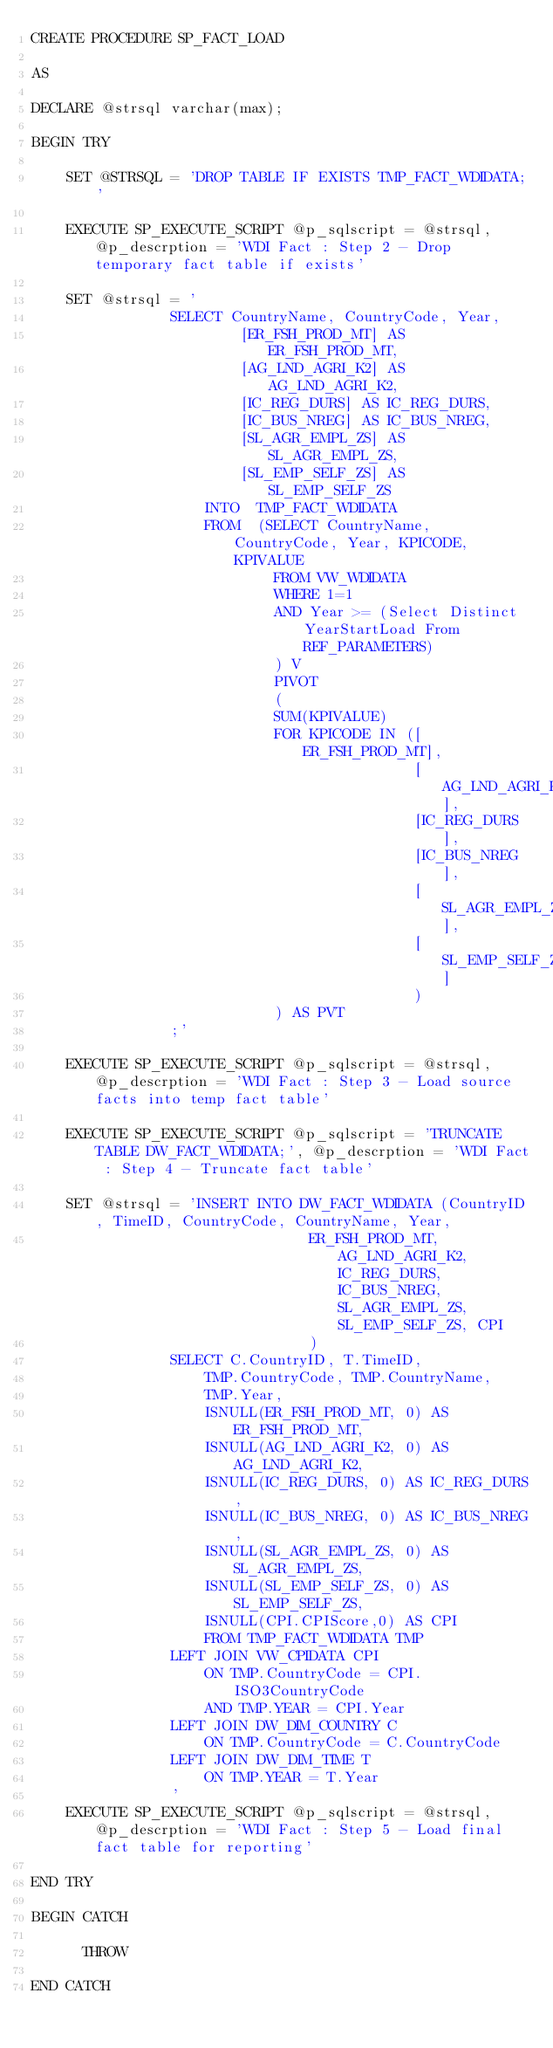<code> <loc_0><loc_0><loc_500><loc_500><_SQL_>CREATE PROCEDURE SP_FACT_LOAD

AS

DECLARE @strsql varchar(max);

BEGIN TRY

    SET @STRSQL = 'DROP TABLE IF EXISTS TMP_FACT_WDIDATA;'
    
    EXECUTE SP_EXECUTE_SCRIPT @p_sqlscript = @strsql, @p_descrption = 'WDI Fact : Step 2 - Drop temporary fact table if exists' 
    
    SET @strsql = '
                SELECT CountryName, CountryCode, Year, 
                        [ER_FSH_PROD_MT] AS ER_FSH_PROD_MT,
                        [AG_LND_AGRI_K2] AS AG_LND_AGRI_K2,
                        [IC_REG_DURS] AS IC_REG_DURS,
                        [IC_BUS_NREG] AS IC_BUS_NREG,
                        [SL_AGR_EMPL_ZS] AS SL_AGR_EMPL_ZS,
                        [SL_EMP_SELF_ZS] AS SL_EMP_SELF_ZS
                    INTO  TMP_FACT_WDIDATA
                    FROM  (SELECT CountryName, CountryCode, Year, KPICODE, KPIVALUE
                            FROM VW_WDIDATA
                            WHERE 1=1
                            AND Year >= (Select Distinct YearStartLoad From REF_PARAMETERS)
                            ) V
                            PIVOT
                            (
                            SUM(KPIVALUE)
                            FOR KPICODE IN ([ER_FSH_PROD_MT],
                                            [AG_LND_AGRI_K2],
                                            [IC_REG_DURS],
                                            [IC_BUS_NREG],
                                            [SL_AGR_EMPL_ZS],
                                            [SL_EMP_SELF_ZS]
                                            )
                            ) AS PVT
                ;'
    
    EXECUTE SP_EXECUTE_SCRIPT @p_sqlscript = @strsql, @p_descrption = 'WDI Fact : Step 3 - Load source facts into temp fact table' 
    
    EXECUTE SP_EXECUTE_SCRIPT @p_sqlscript = 'TRUNCATE TABLE DW_FACT_WDIDATA;', @p_descrption = 'WDI Fact : Step 4 - Truncate fact table' 
    
    SET @strsql = 'INSERT INTO DW_FACT_WDIDATA (CountryID, TimeID, CountryCode, CountryName, Year, 
                                ER_FSH_PROD_MT, AG_LND_AGRI_K2, IC_REG_DURS, IC_BUS_NREG,  SL_AGR_EMPL_ZS, SL_EMP_SELF_ZS, CPI
                                )
                SELECT C.CountryID, T.TimeID, 
                    TMP.CountryCode, TMP.CountryName,
                    TMP.Year,
                    ISNULL(ER_FSH_PROD_MT, 0) AS ER_FSH_PROD_MT,
                    ISNULL(AG_LND_AGRI_K2, 0) AS AG_LND_AGRI_K2,
                    ISNULL(IC_REG_DURS, 0) AS IC_REG_DURS,
                    ISNULL(IC_BUS_NREG, 0) AS IC_BUS_NREG,
                    ISNULL(SL_AGR_EMPL_ZS, 0) AS SL_AGR_EMPL_ZS,
                    ISNULL(SL_EMP_SELF_ZS, 0) AS SL_EMP_SELF_ZS,
                    ISNULL(CPI.CPIScore,0) AS CPI
                    FROM TMP_FACT_WDIDATA TMP
                LEFT JOIN VW_CPIDATA CPI
                    ON TMP.CountryCode = CPI.ISO3CountryCode
                    AND TMP.YEAR = CPI.Year
                LEFT JOIN DW_DIM_COUNTRY C
                    ON TMP.CountryCode = C.CountryCode
                LEFT JOIN DW_DIM_TIME T
                    ON TMP.YEAR = T.Year
                '
    EXECUTE SP_EXECUTE_SCRIPT @p_sqlscript = @strsql, @p_descrption = 'WDI Fact : Step 5 - Load final fact table for reporting' 
    
END TRY
    
BEGIN CATCH
    
      THROW
    
END CATCH</code> 